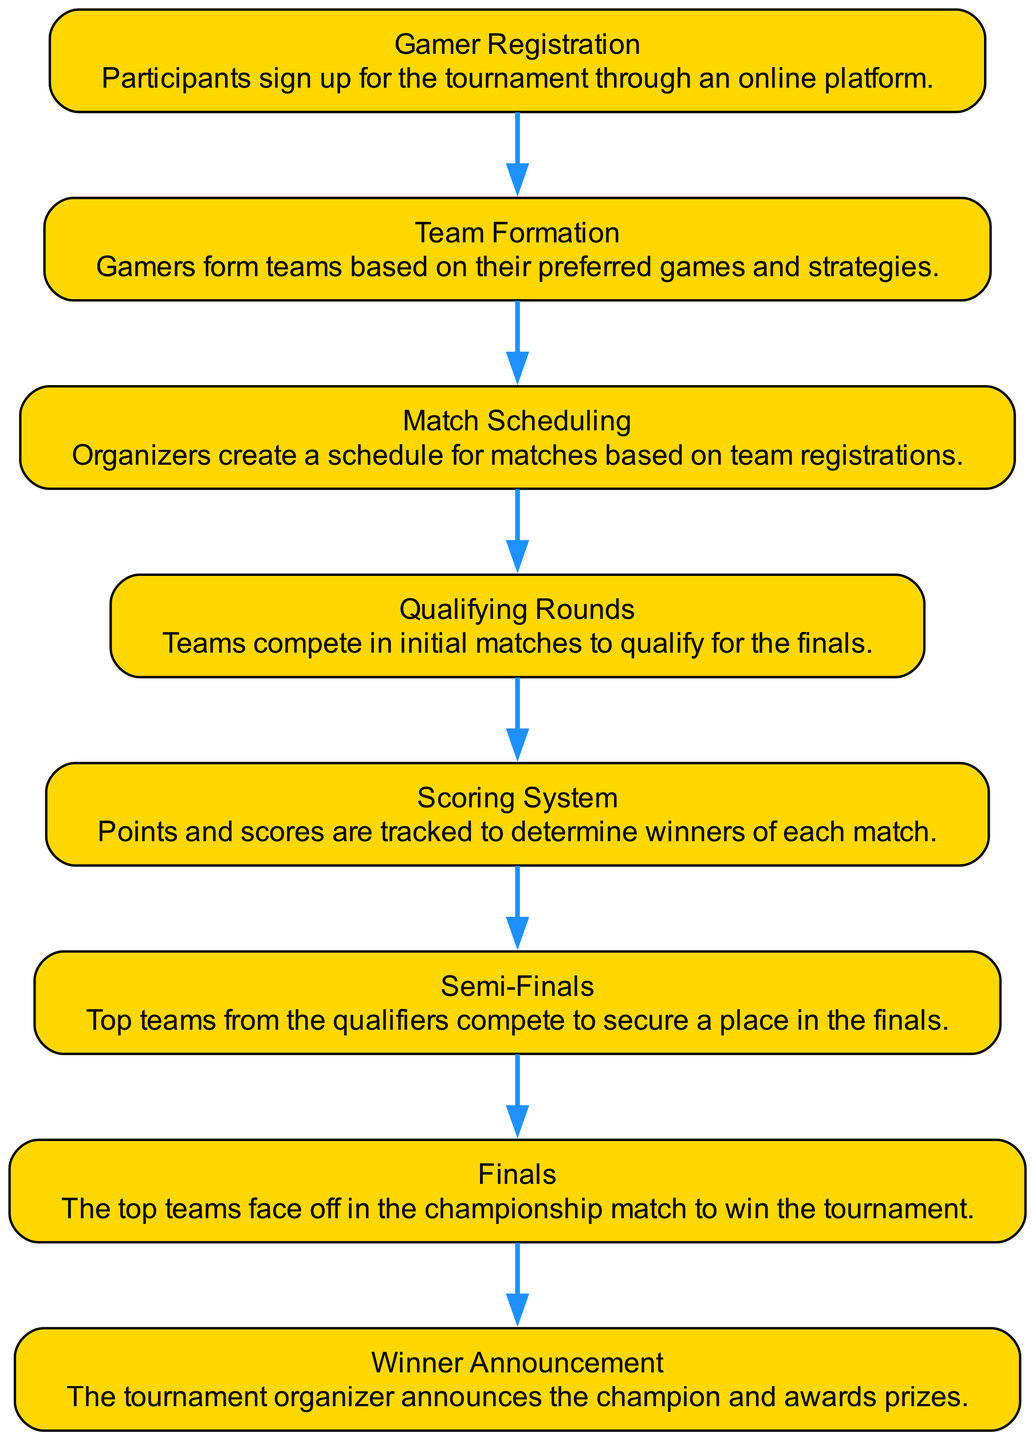What is the first step in the tournament workflow? The first step depicted in the diagram is "Gamer Registration," which shows that participants sign up for the tournament through an online platform.
Answer: Gamer Registration How many main steps are in the workflow? The diagram contains eight main steps detailing the workflow of the gaming tournament from registration to winner announcement.
Answer: Eight What connects "Semi-Finals" to "Finals"? "Semi-Finals" is connected to "Finals" as the preceding step in the tournament workflow where top teams compete to secure a place in the finals.
Answer: Semi-Finals What role does the "Scoring System" play in the workflow? The "Scoring System" is key for tracking points and scores to determine the winners of each match, integral to the tournament's progression.
Answer: Points tracking Which step involves the announcement of the champion? The final step in the workflow detailing the results of the tournament and the announcement of the champion is "Winner Announcement."
Answer: Winner Announcement What occurs after "Qualifying Rounds"? After "Qualifying Rounds," the next event in the workflow is "Semi-Finals," where the top teams compete to advance to the finals.
Answer: Semi-Finals Which step immediately follows "Match Scheduling"? Following "Match Scheduling," the next step in the workflow is "Qualifying Rounds," where teams compete in initial matches.
Answer: Qualifying Rounds Which two processes are connected through a scoring mechanism? "Qualifying Rounds" and "Scoring System" are interconnected as teams compete in matches that generate scores tracked by the scoring system.
Answer: Qualifying Rounds, Scoring System 